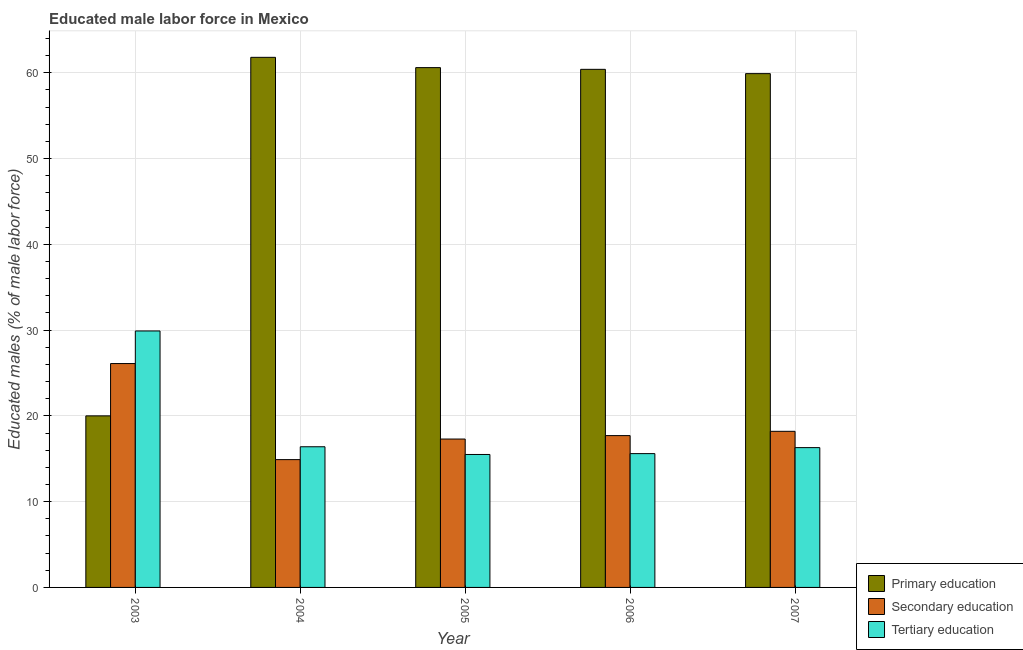How many different coloured bars are there?
Provide a succinct answer. 3. How many groups of bars are there?
Keep it short and to the point. 5. Are the number of bars on each tick of the X-axis equal?
Ensure brevity in your answer.  Yes. What is the percentage of male labor force who received primary education in 2003?
Your answer should be very brief. 20. Across all years, what is the maximum percentage of male labor force who received secondary education?
Your answer should be very brief. 26.1. In which year was the percentage of male labor force who received tertiary education maximum?
Your response must be concise. 2003. What is the total percentage of male labor force who received primary education in the graph?
Offer a terse response. 262.7. What is the difference between the percentage of male labor force who received secondary education in 2004 and that in 2007?
Provide a succinct answer. -3.3. What is the difference between the percentage of male labor force who received tertiary education in 2003 and the percentage of male labor force who received secondary education in 2005?
Your answer should be very brief. 14.4. What is the average percentage of male labor force who received primary education per year?
Your answer should be compact. 52.54. In how many years, is the percentage of male labor force who received primary education greater than 52 %?
Keep it short and to the point. 4. What is the ratio of the percentage of male labor force who received tertiary education in 2005 to that in 2007?
Give a very brief answer. 0.95. Is the percentage of male labor force who received secondary education in 2004 less than that in 2005?
Offer a terse response. Yes. Is the difference between the percentage of male labor force who received secondary education in 2004 and 2005 greater than the difference between the percentage of male labor force who received primary education in 2004 and 2005?
Your answer should be very brief. No. What is the difference between the highest and the second highest percentage of male labor force who received primary education?
Your answer should be compact. 1.2. What is the difference between the highest and the lowest percentage of male labor force who received primary education?
Give a very brief answer. 41.8. In how many years, is the percentage of male labor force who received tertiary education greater than the average percentage of male labor force who received tertiary education taken over all years?
Keep it short and to the point. 1. Is the sum of the percentage of male labor force who received secondary education in 2004 and 2006 greater than the maximum percentage of male labor force who received tertiary education across all years?
Your answer should be very brief. Yes. What does the 1st bar from the left in 2003 represents?
Offer a terse response. Primary education. Is it the case that in every year, the sum of the percentage of male labor force who received primary education and percentage of male labor force who received secondary education is greater than the percentage of male labor force who received tertiary education?
Make the answer very short. Yes. How many bars are there?
Offer a very short reply. 15. Are all the bars in the graph horizontal?
Your answer should be very brief. No. How many years are there in the graph?
Provide a succinct answer. 5. What is the difference between two consecutive major ticks on the Y-axis?
Provide a short and direct response. 10. Are the values on the major ticks of Y-axis written in scientific E-notation?
Provide a succinct answer. No. Does the graph contain any zero values?
Keep it short and to the point. No. Where does the legend appear in the graph?
Give a very brief answer. Bottom right. How many legend labels are there?
Your response must be concise. 3. How are the legend labels stacked?
Your response must be concise. Vertical. What is the title of the graph?
Keep it short and to the point. Educated male labor force in Mexico. Does "Coal" appear as one of the legend labels in the graph?
Your response must be concise. No. What is the label or title of the X-axis?
Provide a short and direct response. Year. What is the label or title of the Y-axis?
Provide a succinct answer. Educated males (% of male labor force). What is the Educated males (% of male labor force) of Secondary education in 2003?
Offer a terse response. 26.1. What is the Educated males (% of male labor force) of Tertiary education in 2003?
Ensure brevity in your answer.  29.9. What is the Educated males (% of male labor force) in Primary education in 2004?
Your response must be concise. 61.8. What is the Educated males (% of male labor force) of Secondary education in 2004?
Offer a very short reply. 14.9. What is the Educated males (% of male labor force) in Tertiary education in 2004?
Ensure brevity in your answer.  16.4. What is the Educated males (% of male labor force) in Primary education in 2005?
Make the answer very short. 60.6. What is the Educated males (% of male labor force) in Secondary education in 2005?
Your answer should be compact. 17.3. What is the Educated males (% of male labor force) of Primary education in 2006?
Keep it short and to the point. 60.4. What is the Educated males (% of male labor force) in Secondary education in 2006?
Make the answer very short. 17.7. What is the Educated males (% of male labor force) of Tertiary education in 2006?
Your answer should be compact. 15.6. What is the Educated males (% of male labor force) of Primary education in 2007?
Ensure brevity in your answer.  59.9. What is the Educated males (% of male labor force) of Secondary education in 2007?
Make the answer very short. 18.2. What is the Educated males (% of male labor force) in Tertiary education in 2007?
Make the answer very short. 16.3. Across all years, what is the maximum Educated males (% of male labor force) in Primary education?
Your answer should be compact. 61.8. Across all years, what is the maximum Educated males (% of male labor force) in Secondary education?
Make the answer very short. 26.1. Across all years, what is the maximum Educated males (% of male labor force) of Tertiary education?
Make the answer very short. 29.9. Across all years, what is the minimum Educated males (% of male labor force) of Secondary education?
Your response must be concise. 14.9. Across all years, what is the minimum Educated males (% of male labor force) in Tertiary education?
Give a very brief answer. 15.5. What is the total Educated males (% of male labor force) of Primary education in the graph?
Offer a terse response. 262.7. What is the total Educated males (% of male labor force) in Secondary education in the graph?
Provide a short and direct response. 94.2. What is the total Educated males (% of male labor force) in Tertiary education in the graph?
Your response must be concise. 93.7. What is the difference between the Educated males (% of male labor force) in Primary education in 2003 and that in 2004?
Ensure brevity in your answer.  -41.8. What is the difference between the Educated males (% of male labor force) in Secondary education in 2003 and that in 2004?
Ensure brevity in your answer.  11.2. What is the difference between the Educated males (% of male labor force) of Tertiary education in 2003 and that in 2004?
Your answer should be very brief. 13.5. What is the difference between the Educated males (% of male labor force) in Primary education in 2003 and that in 2005?
Offer a very short reply. -40.6. What is the difference between the Educated males (% of male labor force) of Secondary education in 2003 and that in 2005?
Your answer should be compact. 8.8. What is the difference between the Educated males (% of male labor force) of Tertiary education in 2003 and that in 2005?
Offer a very short reply. 14.4. What is the difference between the Educated males (% of male labor force) in Primary education in 2003 and that in 2006?
Your answer should be very brief. -40.4. What is the difference between the Educated males (% of male labor force) of Primary education in 2003 and that in 2007?
Offer a very short reply. -39.9. What is the difference between the Educated males (% of male labor force) in Primary education in 2004 and that in 2005?
Give a very brief answer. 1.2. What is the difference between the Educated males (% of male labor force) in Secondary education in 2004 and that in 2005?
Offer a terse response. -2.4. What is the difference between the Educated males (% of male labor force) in Primary education in 2004 and that in 2006?
Offer a very short reply. 1.4. What is the difference between the Educated males (% of male labor force) of Secondary education in 2004 and that in 2006?
Give a very brief answer. -2.8. What is the difference between the Educated males (% of male labor force) of Tertiary education in 2004 and that in 2006?
Keep it short and to the point. 0.8. What is the difference between the Educated males (% of male labor force) of Primary education in 2005 and that in 2006?
Offer a very short reply. 0.2. What is the difference between the Educated males (% of male labor force) of Secondary education in 2005 and that in 2006?
Offer a very short reply. -0.4. What is the difference between the Educated males (% of male labor force) of Primary education in 2005 and that in 2007?
Provide a short and direct response. 0.7. What is the difference between the Educated males (% of male labor force) of Secondary education in 2005 and that in 2007?
Your answer should be compact. -0.9. What is the difference between the Educated males (% of male labor force) in Tertiary education in 2005 and that in 2007?
Provide a short and direct response. -0.8. What is the difference between the Educated males (% of male labor force) of Primary education in 2006 and that in 2007?
Provide a short and direct response. 0.5. What is the difference between the Educated males (% of male labor force) in Secondary education in 2006 and that in 2007?
Offer a very short reply. -0.5. What is the difference between the Educated males (% of male labor force) of Secondary education in 2003 and the Educated males (% of male labor force) of Tertiary education in 2004?
Ensure brevity in your answer.  9.7. What is the difference between the Educated males (% of male labor force) of Primary education in 2003 and the Educated males (% of male labor force) of Secondary education in 2005?
Make the answer very short. 2.7. What is the difference between the Educated males (% of male labor force) of Primary education in 2003 and the Educated males (% of male labor force) of Secondary education in 2006?
Keep it short and to the point. 2.3. What is the difference between the Educated males (% of male labor force) in Primary education in 2003 and the Educated males (% of male labor force) in Tertiary education in 2006?
Provide a short and direct response. 4.4. What is the difference between the Educated males (% of male labor force) of Secondary education in 2003 and the Educated males (% of male labor force) of Tertiary education in 2006?
Offer a very short reply. 10.5. What is the difference between the Educated males (% of male labor force) in Primary education in 2003 and the Educated males (% of male labor force) in Tertiary education in 2007?
Your answer should be very brief. 3.7. What is the difference between the Educated males (% of male labor force) of Secondary education in 2003 and the Educated males (% of male labor force) of Tertiary education in 2007?
Keep it short and to the point. 9.8. What is the difference between the Educated males (% of male labor force) in Primary education in 2004 and the Educated males (% of male labor force) in Secondary education in 2005?
Your answer should be very brief. 44.5. What is the difference between the Educated males (% of male labor force) in Primary education in 2004 and the Educated males (% of male labor force) in Tertiary education in 2005?
Your response must be concise. 46.3. What is the difference between the Educated males (% of male labor force) in Primary education in 2004 and the Educated males (% of male labor force) in Secondary education in 2006?
Provide a succinct answer. 44.1. What is the difference between the Educated males (% of male labor force) in Primary education in 2004 and the Educated males (% of male labor force) in Tertiary education in 2006?
Keep it short and to the point. 46.2. What is the difference between the Educated males (% of male labor force) in Secondary education in 2004 and the Educated males (% of male labor force) in Tertiary education in 2006?
Make the answer very short. -0.7. What is the difference between the Educated males (% of male labor force) in Primary education in 2004 and the Educated males (% of male labor force) in Secondary education in 2007?
Offer a terse response. 43.6. What is the difference between the Educated males (% of male labor force) in Primary education in 2004 and the Educated males (% of male labor force) in Tertiary education in 2007?
Ensure brevity in your answer.  45.5. What is the difference between the Educated males (% of male labor force) in Primary education in 2005 and the Educated males (% of male labor force) in Secondary education in 2006?
Your answer should be very brief. 42.9. What is the difference between the Educated males (% of male labor force) of Primary education in 2005 and the Educated males (% of male labor force) of Tertiary education in 2006?
Provide a succinct answer. 45. What is the difference between the Educated males (% of male labor force) in Secondary education in 2005 and the Educated males (% of male labor force) in Tertiary education in 2006?
Keep it short and to the point. 1.7. What is the difference between the Educated males (% of male labor force) of Primary education in 2005 and the Educated males (% of male labor force) of Secondary education in 2007?
Make the answer very short. 42.4. What is the difference between the Educated males (% of male labor force) in Primary education in 2005 and the Educated males (% of male labor force) in Tertiary education in 2007?
Provide a short and direct response. 44.3. What is the difference between the Educated males (% of male labor force) in Primary education in 2006 and the Educated males (% of male labor force) in Secondary education in 2007?
Your response must be concise. 42.2. What is the difference between the Educated males (% of male labor force) of Primary education in 2006 and the Educated males (% of male labor force) of Tertiary education in 2007?
Provide a short and direct response. 44.1. What is the average Educated males (% of male labor force) in Primary education per year?
Your response must be concise. 52.54. What is the average Educated males (% of male labor force) in Secondary education per year?
Make the answer very short. 18.84. What is the average Educated males (% of male labor force) of Tertiary education per year?
Your answer should be compact. 18.74. In the year 2003, what is the difference between the Educated males (% of male labor force) of Secondary education and Educated males (% of male labor force) of Tertiary education?
Your response must be concise. -3.8. In the year 2004, what is the difference between the Educated males (% of male labor force) of Primary education and Educated males (% of male labor force) of Secondary education?
Keep it short and to the point. 46.9. In the year 2004, what is the difference between the Educated males (% of male labor force) in Primary education and Educated males (% of male labor force) in Tertiary education?
Keep it short and to the point. 45.4. In the year 2005, what is the difference between the Educated males (% of male labor force) of Primary education and Educated males (% of male labor force) of Secondary education?
Your answer should be compact. 43.3. In the year 2005, what is the difference between the Educated males (% of male labor force) of Primary education and Educated males (% of male labor force) of Tertiary education?
Provide a succinct answer. 45.1. In the year 2005, what is the difference between the Educated males (% of male labor force) in Secondary education and Educated males (% of male labor force) in Tertiary education?
Offer a terse response. 1.8. In the year 2006, what is the difference between the Educated males (% of male labor force) in Primary education and Educated males (% of male labor force) in Secondary education?
Your answer should be very brief. 42.7. In the year 2006, what is the difference between the Educated males (% of male labor force) of Primary education and Educated males (% of male labor force) of Tertiary education?
Offer a very short reply. 44.8. In the year 2006, what is the difference between the Educated males (% of male labor force) in Secondary education and Educated males (% of male labor force) in Tertiary education?
Ensure brevity in your answer.  2.1. In the year 2007, what is the difference between the Educated males (% of male labor force) in Primary education and Educated males (% of male labor force) in Secondary education?
Ensure brevity in your answer.  41.7. In the year 2007, what is the difference between the Educated males (% of male labor force) of Primary education and Educated males (% of male labor force) of Tertiary education?
Provide a succinct answer. 43.6. What is the ratio of the Educated males (% of male labor force) in Primary education in 2003 to that in 2004?
Ensure brevity in your answer.  0.32. What is the ratio of the Educated males (% of male labor force) of Secondary education in 2003 to that in 2004?
Offer a terse response. 1.75. What is the ratio of the Educated males (% of male labor force) of Tertiary education in 2003 to that in 2004?
Offer a terse response. 1.82. What is the ratio of the Educated males (% of male labor force) of Primary education in 2003 to that in 2005?
Your answer should be very brief. 0.33. What is the ratio of the Educated males (% of male labor force) in Secondary education in 2003 to that in 2005?
Offer a very short reply. 1.51. What is the ratio of the Educated males (% of male labor force) of Tertiary education in 2003 to that in 2005?
Ensure brevity in your answer.  1.93. What is the ratio of the Educated males (% of male labor force) of Primary education in 2003 to that in 2006?
Make the answer very short. 0.33. What is the ratio of the Educated males (% of male labor force) of Secondary education in 2003 to that in 2006?
Your answer should be compact. 1.47. What is the ratio of the Educated males (% of male labor force) of Tertiary education in 2003 to that in 2006?
Keep it short and to the point. 1.92. What is the ratio of the Educated males (% of male labor force) in Primary education in 2003 to that in 2007?
Give a very brief answer. 0.33. What is the ratio of the Educated males (% of male labor force) of Secondary education in 2003 to that in 2007?
Your answer should be compact. 1.43. What is the ratio of the Educated males (% of male labor force) in Tertiary education in 2003 to that in 2007?
Your response must be concise. 1.83. What is the ratio of the Educated males (% of male labor force) in Primary education in 2004 to that in 2005?
Provide a succinct answer. 1.02. What is the ratio of the Educated males (% of male labor force) in Secondary education in 2004 to that in 2005?
Your answer should be compact. 0.86. What is the ratio of the Educated males (% of male labor force) in Tertiary education in 2004 to that in 2005?
Offer a terse response. 1.06. What is the ratio of the Educated males (% of male labor force) in Primary education in 2004 to that in 2006?
Keep it short and to the point. 1.02. What is the ratio of the Educated males (% of male labor force) in Secondary education in 2004 to that in 2006?
Your response must be concise. 0.84. What is the ratio of the Educated males (% of male labor force) of Tertiary education in 2004 to that in 2006?
Offer a very short reply. 1.05. What is the ratio of the Educated males (% of male labor force) in Primary education in 2004 to that in 2007?
Offer a very short reply. 1.03. What is the ratio of the Educated males (% of male labor force) in Secondary education in 2004 to that in 2007?
Provide a succinct answer. 0.82. What is the ratio of the Educated males (% of male labor force) of Tertiary education in 2004 to that in 2007?
Keep it short and to the point. 1.01. What is the ratio of the Educated males (% of male labor force) of Primary education in 2005 to that in 2006?
Your answer should be very brief. 1. What is the ratio of the Educated males (% of male labor force) in Secondary education in 2005 to that in 2006?
Keep it short and to the point. 0.98. What is the ratio of the Educated males (% of male labor force) in Primary education in 2005 to that in 2007?
Your answer should be compact. 1.01. What is the ratio of the Educated males (% of male labor force) in Secondary education in 2005 to that in 2007?
Offer a terse response. 0.95. What is the ratio of the Educated males (% of male labor force) of Tertiary education in 2005 to that in 2007?
Provide a succinct answer. 0.95. What is the ratio of the Educated males (% of male labor force) in Primary education in 2006 to that in 2007?
Make the answer very short. 1.01. What is the ratio of the Educated males (% of male labor force) of Secondary education in 2006 to that in 2007?
Ensure brevity in your answer.  0.97. What is the ratio of the Educated males (% of male labor force) of Tertiary education in 2006 to that in 2007?
Give a very brief answer. 0.96. What is the difference between the highest and the second highest Educated males (% of male labor force) in Primary education?
Your answer should be very brief. 1.2. What is the difference between the highest and the lowest Educated males (% of male labor force) in Primary education?
Provide a succinct answer. 41.8. What is the difference between the highest and the lowest Educated males (% of male labor force) in Secondary education?
Your response must be concise. 11.2. 